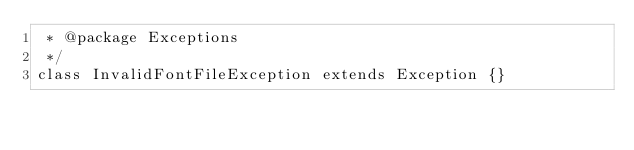<code> <loc_0><loc_0><loc_500><loc_500><_PHP_> * @package Exceptions
 */
class InvalidFontFileException extends Exception {}
</code> 